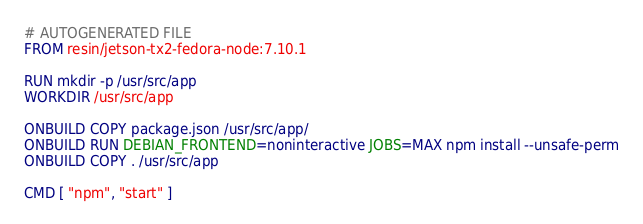<code> <loc_0><loc_0><loc_500><loc_500><_Dockerfile_># AUTOGENERATED FILE
FROM resin/jetson-tx2-fedora-node:7.10.1

RUN mkdir -p /usr/src/app
WORKDIR /usr/src/app

ONBUILD COPY package.json /usr/src/app/
ONBUILD RUN DEBIAN_FRONTEND=noninteractive JOBS=MAX npm install --unsafe-perm
ONBUILD COPY . /usr/src/app

CMD [ "npm", "start" ]
</code> 